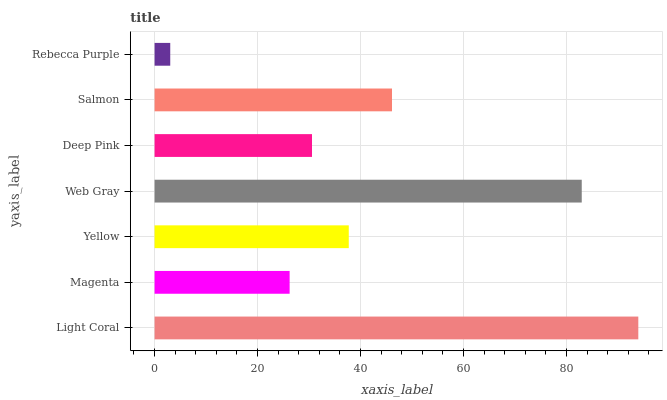Is Rebecca Purple the minimum?
Answer yes or no. Yes. Is Light Coral the maximum?
Answer yes or no. Yes. Is Magenta the minimum?
Answer yes or no. No. Is Magenta the maximum?
Answer yes or no. No. Is Light Coral greater than Magenta?
Answer yes or no. Yes. Is Magenta less than Light Coral?
Answer yes or no. Yes. Is Magenta greater than Light Coral?
Answer yes or no. No. Is Light Coral less than Magenta?
Answer yes or no. No. Is Yellow the high median?
Answer yes or no. Yes. Is Yellow the low median?
Answer yes or no. Yes. Is Magenta the high median?
Answer yes or no. No. Is Web Gray the low median?
Answer yes or no. No. 